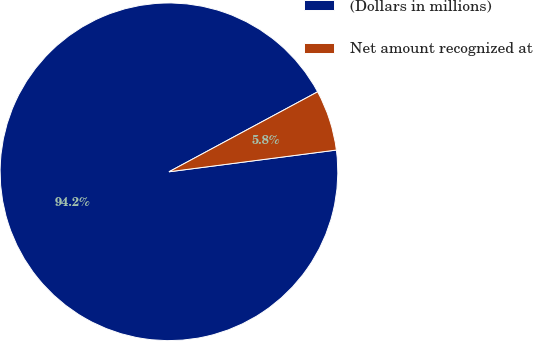<chart> <loc_0><loc_0><loc_500><loc_500><pie_chart><fcel>(Dollars in millions)<fcel>Net amount recognized at<nl><fcel>94.2%<fcel>5.8%<nl></chart> 